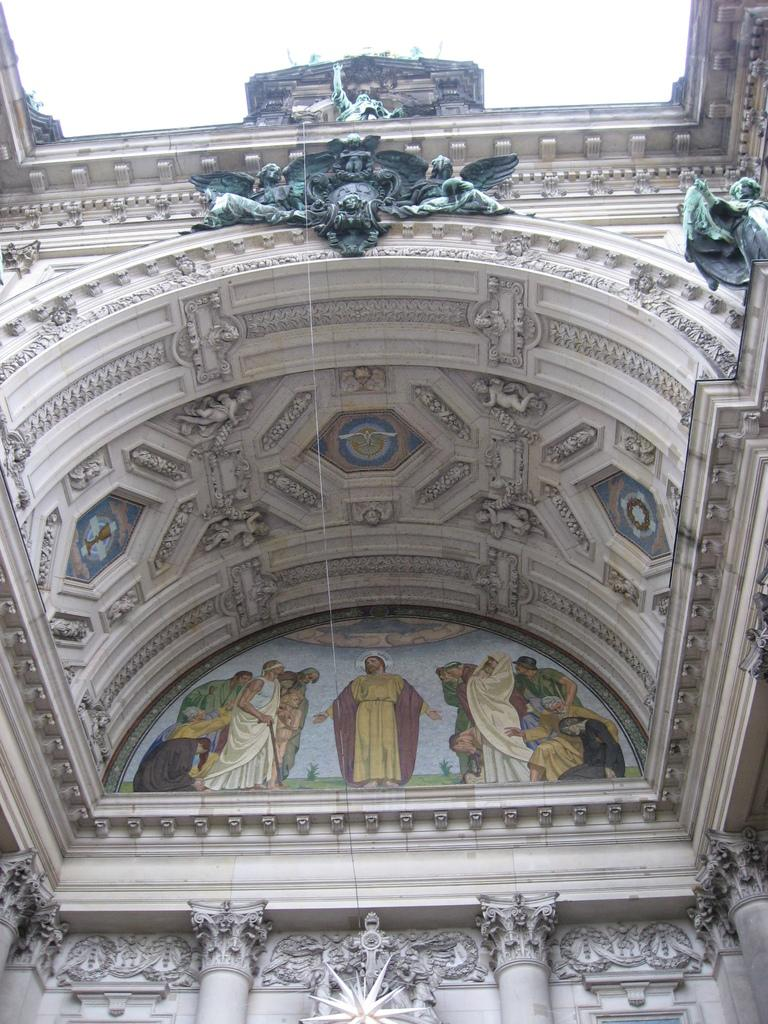What is the main structure in the center of the image? There is a building in the center of the image. What can be seen on the wall of the building? There is a painting on the wall of the building. What architectural features are present at the bottom of the building? There are pillars at the bottom of the building. What decorative elements are present at the top of the building? There are statues at the top of the building. What is visible at the top of the image? The sky is visible at the top of the image. How many cows are grazing in the field next to the building in the image? There is no field or cows present in the image; it features a building with a painting, pillars, and statues. 